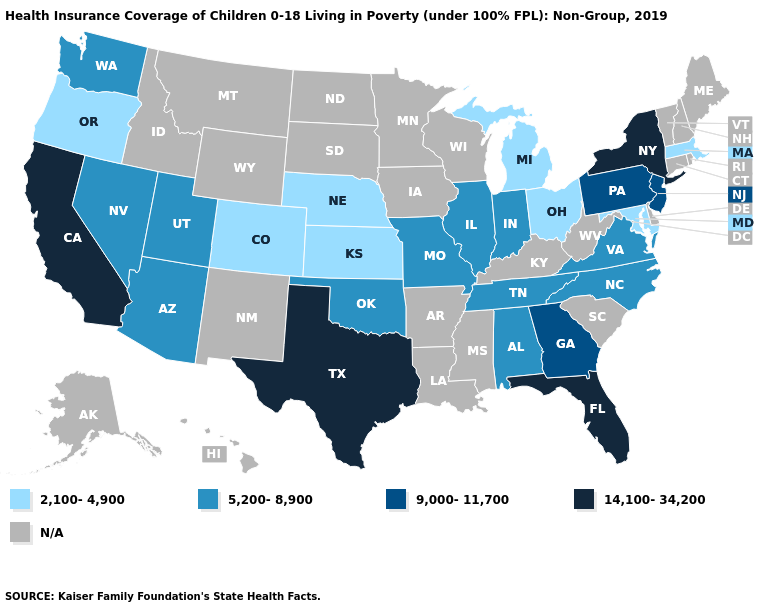What is the lowest value in the MidWest?
Concise answer only. 2,100-4,900. Among the states that border Kentucky , does Ohio have the highest value?
Short answer required. No. Does New York have the highest value in the USA?
Answer briefly. Yes. Name the states that have a value in the range 9,000-11,700?
Quick response, please. Georgia, New Jersey, Pennsylvania. What is the lowest value in the South?
Short answer required. 2,100-4,900. Name the states that have a value in the range 2,100-4,900?
Write a very short answer. Colorado, Kansas, Maryland, Massachusetts, Michigan, Nebraska, Ohio, Oregon. Among the states that border West Virginia , which have the lowest value?
Answer briefly. Maryland, Ohio. Does Florida have the highest value in the South?
Concise answer only. Yes. Which states have the highest value in the USA?
Write a very short answer. California, Florida, New York, Texas. Name the states that have a value in the range 2,100-4,900?
Keep it brief. Colorado, Kansas, Maryland, Massachusetts, Michigan, Nebraska, Ohio, Oregon. Does the map have missing data?
Be succinct. Yes. Which states have the lowest value in the USA?
Give a very brief answer. Colorado, Kansas, Maryland, Massachusetts, Michigan, Nebraska, Ohio, Oregon. How many symbols are there in the legend?
Answer briefly. 5. Name the states that have a value in the range 9,000-11,700?
Answer briefly. Georgia, New Jersey, Pennsylvania. 